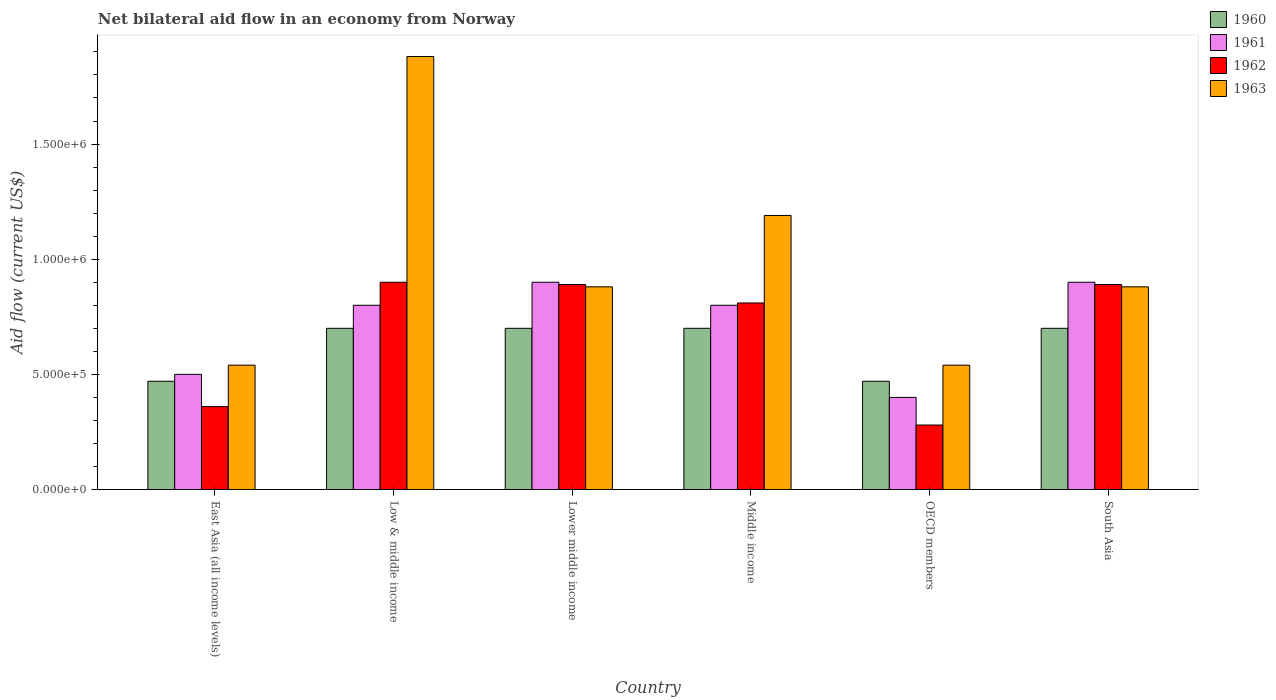How many different coloured bars are there?
Offer a terse response. 4. Are the number of bars on each tick of the X-axis equal?
Your response must be concise. Yes. How many bars are there on the 5th tick from the left?
Ensure brevity in your answer.  4. What is the label of the 1st group of bars from the left?
Your answer should be very brief. East Asia (all income levels). In how many cases, is the number of bars for a given country not equal to the number of legend labels?
Offer a very short reply. 0. Across all countries, what is the minimum net bilateral aid flow in 1963?
Offer a terse response. 5.40e+05. In which country was the net bilateral aid flow in 1961 maximum?
Your answer should be compact. Lower middle income. In which country was the net bilateral aid flow in 1960 minimum?
Provide a succinct answer. East Asia (all income levels). What is the total net bilateral aid flow in 1963 in the graph?
Your response must be concise. 5.91e+06. What is the difference between the net bilateral aid flow in 1963 in Lower middle income and the net bilateral aid flow in 1961 in Middle income?
Provide a short and direct response. 8.00e+04. What is the average net bilateral aid flow in 1961 per country?
Keep it short and to the point. 7.17e+05. What is the ratio of the net bilateral aid flow in 1963 in Low & middle income to that in Middle income?
Provide a short and direct response. 1.58. Is the difference between the net bilateral aid flow in 1963 in Lower middle income and Middle income greater than the difference between the net bilateral aid flow in 1960 in Lower middle income and Middle income?
Provide a short and direct response. No. What is the difference between the highest and the second highest net bilateral aid flow in 1963?
Ensure brevity in your answer.  6.90e+05. What is the difference between the highest and the lowest net bilateral aid flow in 1960?
Your answer should be compact. 2.30e+05. What does the 4th bar from the right in Low & middle income represents?
Keep it short and to the point. 1960. Is it the case that in every country, the sum of the net bilateral aid flow in 1962 and net bilateral aid flow in 1963 is greater than the net bilateral aid flow in 1960?
Ensure brevity in your answer.  Yes. How many bars are there?
Provide a succinct answer. 24. Are all the bars in the graph horizontal?
Give a very brief answer. No. How many countries are there in the graph?
Your response must be concise. 6. Does the graph contain any zero values?
Provide a succinct answer. No. Where does the legend appear in the graph?
Provide a succinct answer. Top right. How many legend labels are there?
Provide a succinct answer. 4. What is the title of the graph?
Your response must be concise. Net bilateral aid flow in an economy from Norway. Does "1981" appear as one of the legend labels in the graph?
Ensure brevity in your answer.  No. What is the label or title of the Y-axis?
Give a very brief answer. Aid flow (current US$). What is the Aid flow (current US$) of 1961 in East Asia (all income levels)?
Your answer should be compact. 5.00e+05. What is the Aid flow (current US$) in 1963 in East Asia (all income levels)?
Offer a terse response. 5.40e+05. What is the Aid flow (current US$) of 1960 in Low & middle income?
Provide a succinct answer. 7.00e+05. What is the Aid flow (current US$) of 1962 in Low & middle income?
Make the answer very short. 9.00e+05. What is the Aid flow (current US$) in 1963 in Low & middle income?
Provide a succinct answer. 1.88e+06. What is the Aid flow (current US$) in 1960 in Lower middle income?
Make the answer very short. 7.00e+05. What is the Aid flow (current US$) in 1962 in Lower middle income?
Offer a terse response. 8.90e+05. What is the Aid flow (current US$) of 1963 in Lower middle income?
Make the answer very short. 8.80e+05. What is the Aid flow (current US$) in 1960 in Middle income?
Ensure brevity in your answer.  7.00e+05. What is the Aid flow (current US$) in 1961 in Middle income?
Your answer should be compact. 8.00e+05. What is the Aid flow (current US$) in 1962 in Middle income?
Your answer should be compact. 8.10e+05. What is the Aid flow (current US$) in 1963 in Middle income?
Provide a succinct answer. 1.19e+06. What is the Aid flow (current US$) of 1960 in OECD members?
Provide a succinct answer. 4.70e+05. What is the Aid flow (current US$) in 1962 in OECD members?
Ensure brevity in your answer.  2.80e+05. What is the Aid flow (current US$) of 1963 in OECD members?
Make the answer very short. 5.40e+05. What is the Aid flow (current US$) in 1962 in South Asia?
Offer a very short reply. 8.90e+05. What is the Aid flow (current US$) in 1963 in South Asia?
Keep it short and to the point. 8.80e+05. Across all countries, what is the maximum Aid flow (current US$) of 1960?
Give a very brief answer. 7.00e+05. Across all countries, what is the maximum Aid flow (current US$) in 1962?
Offer a terse response. 9.00e+05. Across all countries, what is the maximum Aid flow (current US$) of 1963?
Your answer should be very brief. 1.88e+06. Across all countries, what is the minimum Aid flow (current US$) in 1960?
Offer a very short reply. 4.70e+05. Across all countries, what is the minimum Aid flow (current US$) of 1961?
Your response must be concise. 4.00e+05. Across all countries, what is the minimum Aid flow (current US$) of 1962?
Give a very brief answer. 2.80e+05. Across all countries, what is the minimum Aid flow (current US$) in 1963?
Provide a short and direct response. 5.40e+05. What is the total Aid flow (current US$) in 1960 in the graph?
Provide a short and direct response. 3.74e+06. What is the total Aid flow (current US$) in 1961 in the graph?
Your answer should be compact. 4.30e+06. What is the total Aid flow (current US$) in 1962 in the graph?
Keep it short and to the point. 4.13e+06. What is the total Aid flow (current US$) of 1963 in the graph?
Give a very brief answer. 5.91e+06. What is the difference between the Aid flow (current US$) of 1961 in East Asia (all income levels) and that in Low & middle income?
Keep it short and to the point. -3.00e+05. What is the difference between the Aid flow (current US$) in 1962 in East Asia (all income levels) and that in Low & middle income?
Make the answer very short. -5.40e+05. What is the difference between the Aid flow (current US$) of 1963 in East Asia (all income levels) and that in Low & middle income?
Give a very brief answer. -1.34e+06. What is the difference between the Aid flow (current US$) in 1960 in East Asia (all income levels) and that in Lower middle income?
Offer a very short reply. -2.30e+05. What is the difference between the Aid flow (current US$) in 1961 in East Asia (all income levels) and that in Lower middle income?
Your answer should be very brief. -4.00e+05. What is the difference between the Aid flow (current US$) in 1962 in East Asia (all income levels) and that in Lower middle income?
Your response must be concise. -5.30e+05. What is the difference between the Aid flow (current US$) in 1962 in East Asia (all income levels) and that in Middle income?
Ensure brevity in your answer.  -4.50e+05. What is the difference between the Aid flow (current US$) of 1963 in East Asia (all income levels) and that in Middle income?
Make the answer very short. -6.50e+05. What is the difference between the Aid flow (current US$) in 1961 in East Asia (all income levels) and that in OECD members?
Offer a terse response. 1.00e+05. What is the difference between the Aid flow (current US$) in 1962 in East Asia (all income levels) and that in OECD members?
Provide a succinct answer. 8.00e+04. What is the difference between the Aid flow (current US$) of 1963 in East Asia (all income levels) and that in OECD members?
Give a very brief answer. 0. What is the difference between the Aid flow (current US$) in 1960 in East Asia (all income levels) and that in South Asia?
Give a very brief answer. -2.30e+05. What is the difference between the Aid flow (current US$) of 1961 in East Asia (all income levels) and that in South Asia?
Your response must be concise. -4.00e+05. What is the difference between the Aid flow (current US$) of 1962 in East Asia (all income levels) and that in South Asia?
Ensure brevity in your answer.  -5.30e+05. What is the difference between the Aid flow (current US$) of 1962 in Low & middle income and that in Lower middle income?
Keep it short and to the point. 10000. What is the difference between the Aid flow (current US$) in 1963 in Low & middle income and that in Lower middle income?
Offer a very short reply. 1.00e+06. What is the difference between the Aid flow (current US$) of 1961 in Low & middle income and that in Middle income?
Provide a succinct answer. 0. What is the difference between the Aid flow (current US$) in 1962 in Low & middle income and that in Middle income?
Provide a short and direct response. 9.00e+04. What is the difference between the Aid flow (current US$) in 1963 in Low & middle income and that in Middle income?
Make the answer very short. 6.90e+05. What is the difference between the Aid flow (current US$) in 1960 in Low & middle income and that in OECD members?
Offer a terse response. 2.30e+05. What is the difference between the Aid flow (current US$) in 1962 in Low & middle income and that in OECD members?
Ensure brevity in your answer.  6.20e+05. What is the difference between the Aid flow (current US$) of 1963 in Low & middle income and that in OECD members?
Provide a short and direct response. 1.34e+06. What is the difference between the Aid flow (current US$) in 1960 in Low & middle income and that in South Asia?
Your answer should be very brief. 0. What is the difference between the Aid flow (current US$) in 1961 in Low & middle income and that in South Asia?
Keep it short and to the point. -1.00e+05. What is the difference between the Aid flow (current US$) in 1963 in Low & middle income and that in South Asia?
Provide a short and direct response. 1.00e+06. What is the difference between the Aid flow (current US$) of 1961 in Lower middle income and that in Middle income?
Keep it short and to the point. 1.00e+05. What is the difference between the Aid flow (current US$) of 1962 in Lower middle income and that in Middle income?
Your response must be concise. 8.00e+04. What is the difference between the Aid flow (current US$) in 1963 in Lower middle income and that in Middle income?
Your response must be concise. -3.10e+05. What is the difference between the Aid flow (current US$) in 1961 in Lower middle income and that in OECD members?
Your answer should be very brief. 5.00e+05. What is the difference between the Aid flow (current US$) in 1962 in Lower middle income and that in OECD members?
Make the answer very short. 6.10e+05. What is the difference between the Aid flow (current US$) in 1963 in Lower middle income and that in OECD members?
Your response must be concise. 3.40e+05. What is the difference between the Aid flow (current US$) in 1960 in Lower middle income and that in South Asia?
Your response must be concise. 0. What is the difference between the Aid flow (current US$) of 1961 in Lower middle income and that in South Asia?
Give a very brief answer. 0. What is the difference between the Aid flow (current US$) in 1963 in Lower middle income and that in South Asia?
Make the answer very short. 0. What is the difference between the Aid flow (current US$) in 1960 in Middle income and that in OECD members?
Keep it short and to the point. 2.30e+05. What is the difference between the Aid flow (current US$) in 1962 in Middle income and that in OECD members?
Offer a very short reply. 5.30e+05. What is the difference between the Aid flow (current US$) in 1963 in Middle income and that in OECD members?
Offer a terse response. 6.50e+05. What is the difference between the Aid flow (current US$) of 1961 in Middle income and that in South Asia?
Keep it short and to the point. -1.00e+05. What is the difference between the Aid flow (current US$) of 1962 in Middle income and that in South Asia?
Provide a succinct answer. -8.00e+04. What is the difference between the Aid flow (current US$) of 1961 in OECD members and that in South Asia?
Provide a succinct answer. -5.00e+05. What is the difference between the Aid flow (current US$) of 1962 in OECD members and that in South Asia?
Your response must be concise. -6.10e+05. What is the difference between the Aid flow (current US$) of 1963 in OECD members and that in South Asia?
Give a very brief answer. -3.40e+05. What is the difference between the Aid flow (current US$) of 1960 in East Asia (all income levels) and the Aid flow (current US$) of 1961 in Low & middle income?
Offer a very short reply. -3.30e+05. What is the difference between the Aid flow (current US$) in 1960 in East Asia (all income levels) and the Aid flow (current US$) in 1962 in Low & middle income?
Provide a succinct answer. -4.30e+05. What is the difference between the Aid flow (current US$) in 1960 in East Asia (all income levels) and the Aid flow (current US$) in 1963 in Low & middle income?
Provide a succinct answer. -1.41e+06. What is the difference between the Aid flow (current US$) in 1961 in East Asia (all income levels) and the Aid flow (current US$) in 1962 in Low & middle income?
Your response must be concise. -4.00e+05. What is the difference between the Aid flow (current US$) in 1961 in East Asia (all income levels) and the Aid flow (current US$) in 1963 in Low & middle income?
Ensure brevity in your answer.  -1.38e+06. What is the difference between the Aid flow (current US$) of 1962 in East Asia (all income levels) and the Aid flow (current US$) of 1963 in Low & middle income?
Offer a very short reply. -1.52e+06. What is the difference between the Aid flow (current US$) of 1960 in East Asia (all income levels) and the Aid flow (current US$) of 1961 in Lower middle income?
Provide a short and direct response. -4.30e+05. What is the difference between the Aid flow (current US$) of 1960 in East Asia (all income levels) and the Aid flow (current US$) of 1962 in Lower middle income?
Make the answer very short. -4.20e+05. What is the difference between the Aid flow (current US$) in 1960 in East Asia (all income levels) and the Aid flow (current US$) in 1963 in Lower middle income?
Your response must be concise. -4.10e+05. What is the difference between the Aid flow (current US$) in 1961 in East Asia (all income levels) and the Aid flow (current US$) in 1962 in Lower middle income?
Your answer should be compact. -3.90e+05. What is the difference between the Aid flow (current US$) of 1961 in East Asia (all income levels) and the Aid flow (current US$) of 1963 in Lower middle income?
Give a very brief answer. -3.80e+05. What is the difference between the Aid flow (current US$) in 1962 in East Asia (all income levels) and the Aid flow (current US$) in 1963 in Lower middle income?
Ensure brevity in your answer.  -5.20e+05. What is the difference between the Aid flow (current US$) in 1960 in East Asia (all income levels) and the Aid flow (current US$) in 1961 in Middle income?
Your answer should be very brief. -3.30e+05. What is the difference between the Aid flow (current US$) of 1960 in East Asia (all income levels) and the Aid flow (current US$) of 1962 in Middle income?
Offer a terse response. -3.40e+05. What is the difference between the Aid flow (current US$) of 1960 in East Asia (all income levels) and the Aid flow (current US$) of 1963 in Middle income?
Offer a very short reply. -7.20e+05. What is the difference between the Aid flow (current US$) of 1961 in East Asia (all income levels) and the Aid flow (current US$) of 1962 in Middle income?
Provide a succinct answer. -3.10e+05. What is the difference between the Aid flow (current US$) of 1961 in East Asia (all income levels) and the Aid flow (current US$) of 1963 in Middle income?
Give a very brief answer. -6.90e+05. What is the difference between the Aid flow (current US$) in 1962 in East Asia (all income levels) and the Aid flow (current US$) in 1963 in Middle income?
Keep it short and to the point. -8.30e+05. What is the difference between the Aid flow (current US$) of 1961 in East Asia (all income levels) and the Aid flow (current US$) of 1963 in OECD members?
Make the answer very short. -4.00e+04. What is the difference between the Aid flow (current US$) in 1962 in East Asia (all income levels) and the Aid flow (current US$) in 1963 in OECD members?
Provide a succinct answer. -1.80e+05. What is the difference between the Aid flow (current US$) in 1960 in East Asia (all income levels) and the Aid flow (current US$) in 1961 in South Asia?
Your response must be concise. -4.30e+05. What is the difference between the Aid flow (current US$) in 1960 in East Asia (all income levels) and the Aid flow (current US$) in 1962 in South Asia?
Ensure brevity in your answer.  -4.20e+05. What is the difference between the Aid flow (current US$) in 1960 in East Asia (all income levels) and the Aid flow (current US$) in 1963 in South Asia?
Offer a very short reply. -4.10e+05. What is the difference between the Aid flow (current US$) of 1961 in East Asia (all income levels) and the Aid flow (current US$) of 1962 in South Asia?
Your answer should be compact. -3.90e+05. What is the difference between the Aid flow (current US$) of 1961 in East Asia (all income levels) and the Aid flow (current US$) of 1963 in South Asia?
Ensure brevity in your answer.  -3.80e+05. What is the difference between the Aid flow (current US$) of 1962 in East Asia (all income levels) and the Aid flow (current US$) of 1963 in South Asia?
Make the answer very short. -5.20e+05. What is the difference between the Aid flow (current US$) in 1961 in Low & middle income and the Aid flow (current US$) in 1962 in Lower middle income?
Ensure brevity in your answer.  -9.00e+04. What is the difference between the Aid flow (current US$) in 1960 in Low & middle income and the Aid flow (current US$) in 1961 in Middle income?
Provide a short and direct response. -1.00e+05. What is the difference between the Aid flow (current US$) in 1960 in Low & middle income and the Aid flow (current US$) in 1962 in Middle income?
Give a very brief answer. -1.10e+05. What is the difference between the Aid flow (current US$) in 1960 in Low & middle income and the Aid flow (current US$) in 1963 in Middle income?
Provide a short and direct response. -4.90e+05. What is the difference between the Aid flow (current US$) of 1961 in Low & middle income and the Aid flow (current US$) of 1963 in Middle income?
Your response must be concise. -3.90e+05. What is the difference between the Aid flow (current US$) in 1960 in Low & middle income and the Aid flow (current US$) in 1961 in OECD members?
Keep it short and to the point. 3.00e+05. What is the difference between the Aid flow (current US$) in 1960 in Low & middle income and the Aid flow (current US$) in 1962 in OECD members?
Make the answer very short. 4.20e+05. What is the difference between the Aid flow (current US$) of 1960 in Low & middle income and the Aid flow (current US$) of 1963 in OECD members?
Keep it short and to the point. 1.60e+05. What is the difference between the Aid flow (current US$) in 1961 in Low & middle income and the Aid flow (current US$) in 1962 in OECD members?
Provide a short and direct response. 5.20e+05. What is the difference between the Aid flow (current US$) in 1960 in Low & middle income and the Aid flow (current US$) in 1961 in South Asia?
Your response must be concise. -2.00e+05. What is the difference between the Aid flow (current US$) of 1960 in Low & middle income and the Aid flow (current US$) of 1963 in South Asia?
Offer a terse response. -1.80e+05. What is the difference between the Aid flow (current US$) in 1961 in Low & middle income and the Aid flow (current US$) in 1963 in South Asia?
Offer a terse response. -8.00e+04. What is the difference between the Aid flow (current US$) of 1960 in Lower middle income and the Aid flow (current US$) of 1961 in Middle income?
Keep it short and to the point. -1.00e+05. What is the difference between the Aid flow (current US$) in 1960 in Lower middle income and the Aid flow (current US$) in 1963 in Middle income?
Your answer should be compact. -4.90e+05. What is the difference between the Aid flow (current US$) of 1961 in Lower middle income and the Aid flow (current US$) of 1962 in Middle income?
Your answer should be very brief. 9.00e+04. What is the difference between the Aid flow (current US$) in 1961 in Lower middle income and the Aid flow (current US$) in 1963 in Middle income?
Give a very brief answer. -2.90e+05. What is the difference between the Aid flow (current US$) in 1960 in Lower middle income and the Aid flow (current US$) in 1962 in OECD members?
Provide a short and direct response. 4.20e+05. What is the difference between the Aid flow (current US$) of 1960 in Lower middle income and the Aid flow (current US$) of 1963 in OECD members?
Ensure brevity in your answer.  1.60e+05. What is the difference between the Aid flow (current US$) in 1961 in Lower middle income and the Aid flow (current US$) in 1962 in OECD members?
Provide a succinct answer. 6.20e+05. What is the difference between the Aid flow (current US$) of 1961 in Lower middle income and the Aid flow (current US$) of 1963 in OECD members?
Provide a succinct answer. 3.60e+05. What is the difference between the Aid flow (current US$) of 1960 in Lower middle income and the Aid flow (current US$) of 1961 in South Asia?
Offer a terse response. -2.00e+05. What is the difference between the Aid flow (current US$) of 1960 in Lower middle income and the Aid flow (current US$) of 1963 in South Asia?
Offer a very short reply. -1.80e+05. What is the difference between the Aid flow (current US$) of 1961 in Lower middle income and the Aid flow (current US$) of 1963 in South Asia?
Offer a very short reply. 2.00e+04. What is the difference between the Aid flow (current US$) in 1962 in Lower middle income and the Aid flow (current US$) in 1963 in South Asia?
Give a very brief answer. 10000. What is the difference between the Aid flow (current US$) in 1961 in Middle income and the Aid flow (current US$) in 1962 in OECD members?
Ensure brevity in your answer.  5.20e+05. What is the difference between the Aid flow (current US$) in 1962 in Middle income and the Aid flow (current US$) in 1963 in OECD members?
Ensure brevity in your answer.  2.70e+05. What is the difference between the Aid flow (current US$) of 1960 in Middle income and the Aid flow (current US$) of 1962 in South Asia?
Your answer should be very brief. -1.90e+05. What is the difference between the Aid flow (current US$) of 1961 in Middle income and the Aid flow (current US$) of 1963 in South Asia?
Ensure brevity in your answer.  -8.00e+04. What is the difference between the Aid flow (current US$) of 1960 in OECD members and the Aid flow (current US$) of 1961 in South Asia?
Offer a very short reply. -4.30e+05. What is the difference between the Aid flow (current US$) of 1960 in OECD members and the Aid flow (current US$) of 1962 in South Asia?
Keep it short and to the point. -4.20e+05. What is the difference between the Aid flow (current US$) of 1960 in OECD members and the Aid flow (current US$) of 1963 in South Asia?
Provide a short and direct response. -4.10e+05. What is the difference between the Aid flow (current US$) of 1961 in OECD members and the Aid flow (current US$) of 1962 in South Asia?
Offer a very short reply. -4.90e+05. What is the difference between the Aid flow (current US$) of 1961 in OECD members and the Aid flow (current US$) of 1963 in South Asia?
Give a very brief answer. -4.80e+05. What is the difference between the Aid flow (current US$) of 1962 in OECD members and the Aid flow (current US$) of 1963 in South Asia?
Make the answer very short. -6.00e+05. What is the average Aid flow (current US$) in 1960 per country?
Your answer should be very brief. 6.23e+05. What is the average Aid flow (current US$) in 1961 per country?
Give a very brief answer. 7.17e+05. What is the average Aid flow (current US$) of 1962 per country?
Offer a terse response. 6.88e+05. What is the average Aid flow (current US$) of 1963 per country?
Offer a very short reply. 9.85e+05. What is the difference between the Aid flow (current US$) of 1960 and Aid flow (current US$) of 1961 in East Asia (all income levels)?
Offer a very short reply. -3.00e+04. What is the difference between the Aid flow (current US$) of 1960 and Aid flow (current US$) of 1963 in East Asia (all income levels)?
Ensure brevity in your answer.  -7.00e+04. What is the difference between the Aid flow (current US$) of 1961 and Aid flow (current US$) of 1962 in East Asia (all income levels)?
Your answer should be compact. 1.40e+05. What is the difference between the Aid flow (current US$) in 1961 and Aid flow (current US$) in 1963 in East Asia (all income levels)?
Offer a terse response. -4.00e+04. What is the difference between the Aid flow (current US$) in 1962 and Aid flow (current US$) in 1963 in East Asia (all income levels)?
Your answer should be very brief. -1.80e+05. What is the difference between the Aid flow (current US$) of 1960 and Aid flow (current US$) of 1961 in Low & middle income?
Offer a very short reply. -1.00e+05. What is the difference between the Aid flow (current US$) of 1960 and Aid flow (current US$) of 1962 in Low & middle income?
Ensure brevity in your answer.  -2.00e+05. What is the difference between the Aid flow (current US$) in 1960 and Aid flow (current US$) in 1963 in Low & middle income?
Provide a succinct answer. -1.18e+06. What is the difference between the Aid flow (current US$) of 1961 and Aid flow (current US$) of 1963 in Low & middle income?
Your response must be concise. -1.08e+06. What is the difference between the Aid flow (current US$) in 1962 and Aid flow (current US$) in 1963 in Low & middle income?
Your answer should be compact. -9.80e+05. What is the difference between the Aid flow (current US$) of 1960 and Aid flow (current US$) of 1961 in Lower middle income?
Your answer should be very brief. -2.00e+05. What is the difference between the Aid flow (current US$) of 1960 and Aid flow (current US$) of 1962 in Lower middle income?
Give a very brief answer. -1.90e+05. What is the difference between the Aid flow (current US$) in 1961 and Aid flow (current US$) in 1962 in Lower middle income?
Your answer should be compact. 10000. What is the difference between the Aid flow (current US$) of 1960 and Aid flow (current US$) of 1961 in Middle income?
Your answer should be compact. -1.00e+05. What is the difference between the Aid flow (current US$) of 1960 and Aid flow (current US$) of 1963 in Middle income?
Give a very brief answer. -4.90e+05. What is the difference between the Aid flow (current US$) of 1961 and Aid flow (current US$) of 1962 in Middle income?
Your answer should be very brief. -10000. What is the difference between the Aid flow (current US$) in 1961 and Aid flow (current US$) in 1963 in Middle income?
Provide a short and direct response. -3.90e+05. What is the difference between the Aid flow (current US$) in 1962 and Aid flow (current US$) in 1963 in Middle income?
Keep it short and to the point. -3.80e+05. What is the difference between the Aid flow (current US$) of 1960 and Aid flow (current US$) of 1961 in OECD members?
Ensure brevity in your answer.  7.00e+04. What is the difference between the Aid flow (current US$) of 1960 and Aid flow (current US$) of 1962 in OECD members?
Your answer should be compact. 1.90e+05. What is the difference between the Aid flow (current US$) of 1961 and Aid flow (current US$) of 1963 in OECD members?
Make the answer very short. -1.40e+05. What is the difference between the Aid flow (current US$) of 1960 and Aid flow (current US$) of 1963 in South Asia?
Provide a succinct answer. -1.80e+05. What is the difference between the Aid flow (current US$) in 1961 and Aid flow (current US$) in 1962 in South Asia?
Your answer should be very brief. 10000. What is the difference between the Aid flow (current US$) in 1961 and Aid flow (current US$) in 1963 in South Asia?
Your answer should be very brief. 2.00e+04. What is the difference between the Aid flow (current US$) in 1962 and Aid flow (current US$) in 1963 in South Asia?
Keep it short and to the point. 10000. What is the ratio of the Aid flow (current US$) of 1960 in East Asia (all income levels) to that in Low & middle income?
Ensure brevity in your answer.  0.67. What is the ratio of the Aid flow (current US$) in 1961 in East Asia (all income levels) to that in Low & middle income?
Offer a very short reply. 0.62. What is the ratio of the Aid flow (current US$) of 1963 in East Asia (all income levels) to that in Low & middle income?
Your response must be concise. 0.29. What is the ratio of the Aid flow (current US$) of 1960 in East Asia (all income levels) to that in Lower middle income?
Your response must be concise. 0.67. What is the ratio of the Aid flow (current US$) in 1961 in East Asia (all income levels) to that in Lower middle income?
Your response must be concise. 0.56. What is the ratio of the Aid flow (current US$) of 1962 in East Asia (all income levels) to that in Lower middle income?
Your answer should be compact. 0.4. What is the ratio of the Aid flow (current US$) in 1963 in East Asia (all income levels) to that in Lower middle income?
Provide a short and direct response. 0.61. What is the ratio of the Aid flow (current US$) of 1960 in East Asia (all income levels) to that in Middle income?
Provide a succinct answer. 0.67. What is the ratio of the Aid flow (current US$) in 1962 in East Asia (all income levels) to that in Middle income?
Keep it short and to the point. 0.44. What is the ratio of the Aid flow (current US$) of 1963 in East Asia (all income levels) to that in Middle income?
Your answer should be very brief. 0.45. What is the ratio of the Aid flow (current US$) of 1961 in East Asia (all income levels) to that in OECD members?
Give a very brief answer. 1.25. What is the ratio of the Aid flow (current US$) of 1962 in East Asia (all income levels) to that in OECD members?
Offer a terse response. 1.29. What is the ratio of the Aid flow (current US$) in 1963 in East Asia (all income levels) to that in OECD members?
Your answer should be very brief. 1. What is the ratio of the Aid flow (current US$) in 1960 in East Asia (all income levels) to that in South Asia?
Provide a short and direct response. 0.67. What is the ratio of the Aid flow (current US$) in 1961 in East Asia (all income levels) to that in South Asia?
Give a very brief answer. 0.56. What is the ratio of the Aid flow (current US$) in 1962 in East Asia (all income levels) to that in South Asia?
Your response must be concise. 0.4. What is the ratio of the Aid flow (current US$) in 1963 in East Asia (all income levels) to that in South Asia?
Keep it short and to the point. 0.61. What is the ratio of the Aid flow (current US$) in 1961 in Low & middle income to that in Lower middle income?
Offer a terse response. 0.89. What is the ratio of the Aid flow (current US$) in 1962 in Low & middle income to that in Lower middle income?
Your answer should be compact. 1.01. What is the ratio of the Aid flow (current US$) of 1963 in Low & middle income to that in Lower middle income?
Your answer should be compact. 2.14. What is the ratio of the Aid flow (current US$) of 1963 in Low & middle income to that in Middle income?
Your answer should be very brief. 1.58. What is the ratio of the Aid flow (current US$) in 1960 in Low & middle income to that in OECD members?
Give a very brief answer. 1.49. What is the ratio of the Aid flow (current US$) of 1961 in Low & middle income to that in OECD members?
Provide a succinct answer. 2. What is the ratio of the Aid flow (current US$) of 1962 in Low & middle income to that in OECD members?
Keep it short and to the point. 3.21. What is the ratio of the Aid flow (current US$) of 1963 in Low & middle income to that in OECD members?
Your response must be concise. 3.48. What is the ratio of the Aid flow (current US$) in 1962 in Low & middle income to that in South Asia?
Make the answer very short. 1.01. What is the ratio of the Aid flow (current US$) in 1963 in Low & middle income to that in South Asia?
Offer a terse response. 2.14. What is the ratio of the Aid flow (current US$) in 1960 in Lower middle income to that in Middle income?
Provide a succinct answer. 1. What is the ratio of the Aid flow (current US$) of 1962 in Lower middle income to that in Middle income?
Give a very brief answer. 1.1. What is the ratio of the Aid flow (current US$) of 1963 in Lower middle income to that in Middle income?
Your answer should be compact. 0.74. What is the ratio of the Aid flow (current US$) in 1960 in Lower middle income to that in OECD members?
Give a very brief answer. 1.49. What is the ratio of the Aid flow (current US$) in 1961 in Lower middle income to that in OECD members?
Give a very brief answer. 2.25. What is the ratio of the Aid flow (current US$) of 1962 in Lower middle income to that in OECD members?
Make the answer very short. 3.18. What is the ratio of the Aid flow (current US$) in 1963 in Lower middle income to that in OECD members?
Your answer should be very brief. 1.63. What is the ratio of the Aid flow (current US$) in 1963 in Lower middle income to that in South Asia?
Make the answer very short. 1. What is the ratio of the Aid flow (current US$) of 1960 in Middle income to that in OECD members?
Your response must be concise. 1.49. What is the ratio of the Aid flow (current US$) of 1961 in Middle income to that in OECD members?
Provide a succinct answer. 2. What is the ratio of the Aid flow (current US$) of 1962 in Middle income to that in OECD members?
Offer a very short reply. 2.89. What is the ratio of the Aid flow (current US$) of 1963 in Middle income to that in OECD members?
Offer a terse response. 2.2. What is the ratio of the Aid flow (current US$) in 1960 in Middle income to that in South Asia?
Ensure brevity in your answer.  1. What is the ratio of the Aid flow (current US$) of 1961 in Middle income to that in South Asia?
Make the answer very short. 0.89. What is the ratio of the Aid flow (current US$) of 1962 in Middle income to that in South Asia?
Offer a very short reply. 0.91. What is the ratio of the Aid flow (current US$) of 1963 in Middle income to that in South Asia?
Provide a succinct answer. 1.35. What is the ratio of the Aid flow (current US$) in 1960 in OECD members to that in South Asia?
Your answer should be very brief. 0.67. What is the ratio of the Aid flow (current US$) of 1961 in OECD members to that in South Asia?
Your response must be concise. 0.44. What is the ratio of the Aid flow (current US$) in 1962 in OECD members to that in South Asia?
Your answer should be very brief. 0.31. What is the ratio of the Aid flow (current US$) of 1963 in OECD members to that in South Asia?
Your response must be concise. 0.61. What is the difference between the highest and the second highest Aid flow (current US$) in 1962?
Offer a very short reply. 10000. What is the difference between the highest and the second highest Aid flow (current US$) of 1963?
Offer a very short reply. 6.90e+05. What is the difference between the highest and the lowest Aid flow (current US$) of 1960?
Offer a terse response. 2.30e+05. What is the difference between the highest and the lowest Aid flow (current US$) in 1961?
Your answer should be very brief. 5.00e+05. What is the difference between the highest and the lowest Aid flow (current US$) in 1962?
Give a very brief answer. 6.20e+05. What is the difference between the highest and the lowest Aid flow (current US$) in 1963?
Provide a succinct answer. 1.34e+06. 